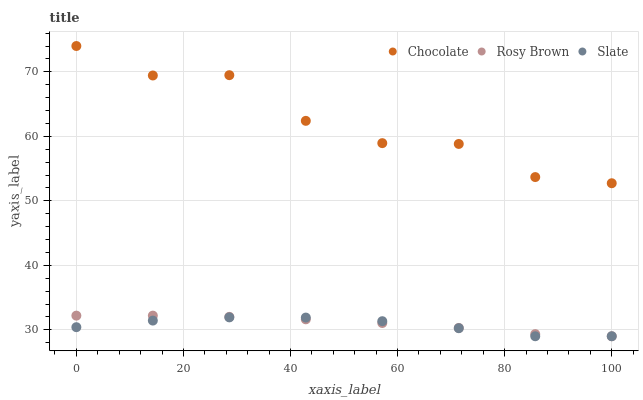Does Slate have the minimum area under the curve?
Answer yes or no. Yes. Does Chocolate have the maximum area under the curve?
Answer yes or no. Yes. Does Rosy Brown have the minimum area under the curve?
Answer yes or no. No. Does Rosy Brown have the maximum area under the curve?
Answer yes or no. No. Is Rosy Brown the smoothest?
Answer yes or no. Yes. Is Chocolate the roughest?
Answer yes or no. Yes. Is Chocolate the smoothest?
Answer yes or no. No. Is Rosy Brown the roughest?
Answer yes or no. No. Does Slate have the lowest value?
Answer yes or no. Yes. Does Chocolate have the lowest value?
Answer yes or no. No. Does Chocolate have the highest value?
Answer yes or no. Yes. Does Rosy Brown have the highest value?
Answer yes or no. No. Is Rosy Brown less than Chocolate?
Answer yes or no. Yes. Is Chocolate greater than Slate?
Answer yes or no. Yes. Does Slate intersect Rosy Brown?
Answer yes or no. Yes. Is Slate less than Rosy Brown?
Answer yes or no. No. Is Slate greater than Rosy Brown?
Answer yes or no. No. Does Rosy Brown intersect Chocolate?
Answer yes or no. No. 